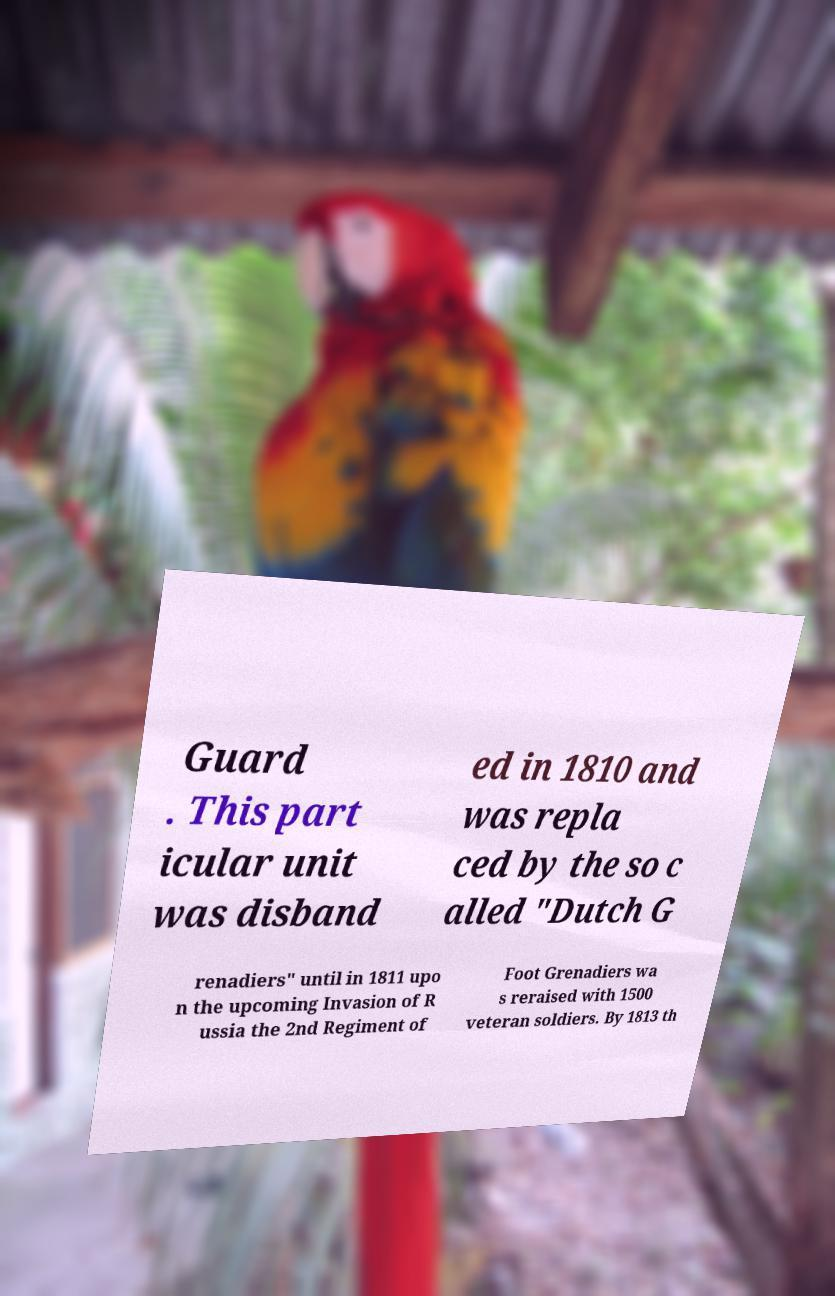What messages or text are displayed in this image? I need them in a readable, typed format. Guard . This part icular unit was disband ed in 1810 and was repla ced by the so c alled "Dutch G renadiers" until in 1811 upo n the upcoming Invasion of R ussia the 2nd Regiment of Foot Grenadiers wa s reraised with 1500 veteran soldiers. By 1813 th 